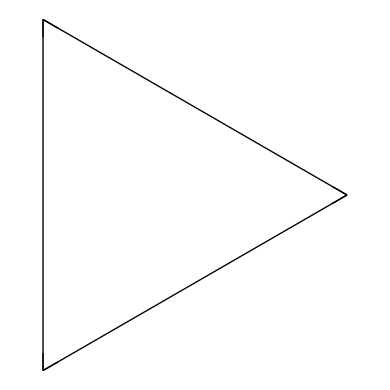What is the name of this chemical? The SMILES representation "C1CC1" corresponds to a three-membered carbon ring, which is known as cyclopropane.
Answer: cyclopropane How many carbon atoms are in cyclopropane? The structure indicates there are three carbon atoms, as represented by the three "C" symbols in the SMILES.
Answer: three How many hydrogen atoms are associated with cyclopropane? Each carbon atom in cyclopropane is bonded to two hydrogen atoms, leading to a total of six hydrogen atoms (3 carbons x 2 hydrogens).
Answer: six What type of structure does cyclopropane have? Cyclopropane has a cyclic structure characterized by a ring of carbon atoms connected by single bonds, defining it as a cycloalkane.
Answer: cyclic Why is cyclopropane considered an efficient anesthetic agent? Cyclopropane's unique cyclic structure allows it to diffuse rapidly in the bloodstream and generate anesthesia quickly, making it effective for medical use.
Answer: rapid diffusion How does the bond angle in cyclopropane influence its reactivity? The bond angles in cyclopropane are approximately 60 degrees, which causes angle strain, leading to increased reactivity compared to less strained cycloalkanes.
Answer: increased reactivity What is the significance of cyclopropane's molecular strain in anesthesia? The molecular strain in cyclopropane can contribute to its anesthetic properties, as the energy associated with strain can facilitate quick onset and offset of anesthesia.
Answer: quick onset and offset 